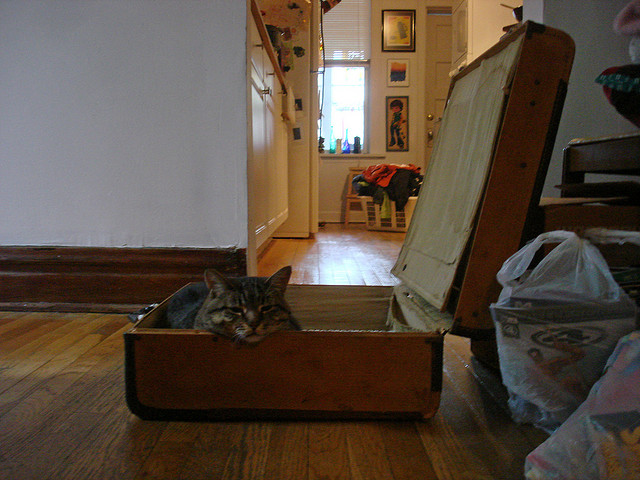<image>What superhero is on the blanket? There is no superhero on the blanket in the image. However, it can be seen that the blanket contains 'catwoman', 'superman', 'spiderman', or 'iron man'. Is the cat going on vacation? The answer is ambiguous as cats typically do not go on vacation. What superhero is on the blanket? I don't know what superhero is on the blanket. It can be seen 'catwoman', 'superman', 'spiderman' or 'iron man'. Is the cat going on vacation? I don't know if the cat is going on vacation. But it seems that it is highly unlikely. 